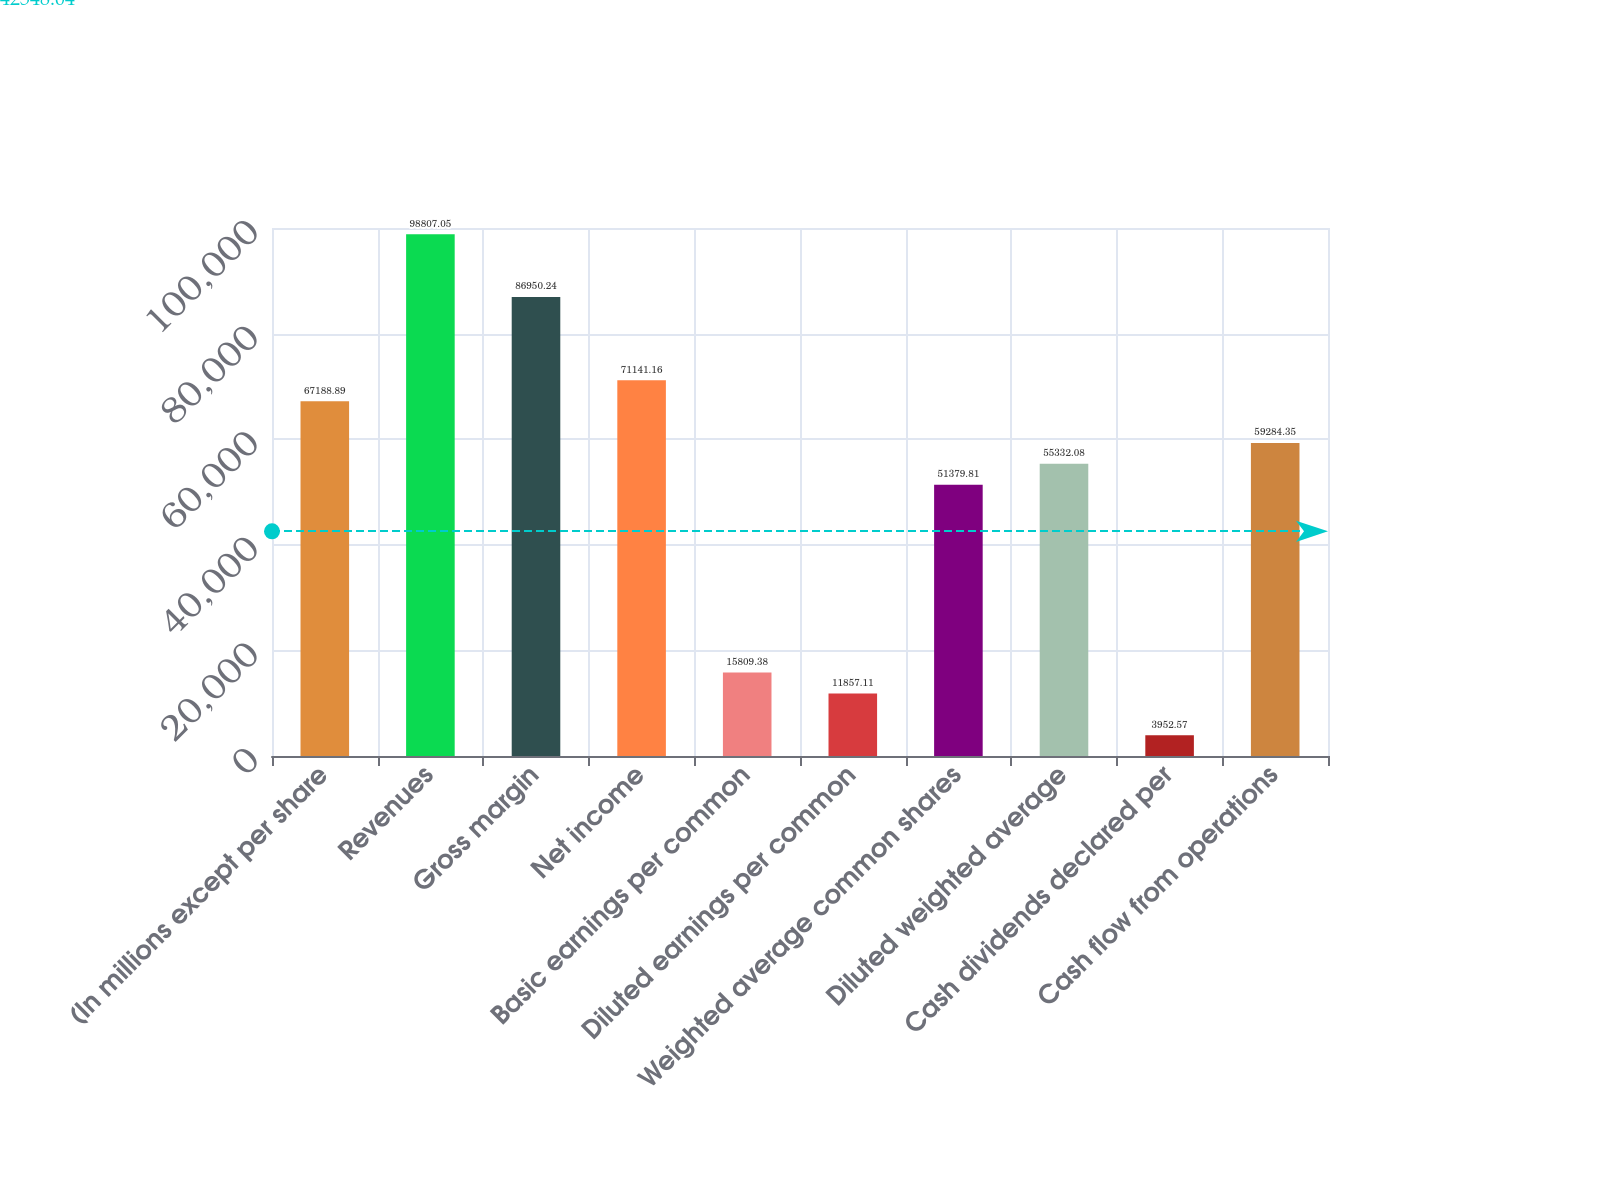Convert chart to OTSL. <chart><loc_0><loc_0><loc_500><loc_500><bar_chart><fcel>(In millions except per share<fcel>Revenues<fcel>Gross margin<fcel>Net income<fcel>Basic earnings per common<fcel>Diluted earnings per common<fcel>Weighted average common shares<fcel>Diluted weighted average<fcel>Cash dividends declared per<fcel>Cash flow from operations<nl><fcel>67188.9<fcel>98807.1<fcel>86950.2<fcel>71141.2<fcel>15809.4<fcel>11857.1<fcel>51379.8<fcel>55332.1<fcel>3952.57<fcel>59284.3<nl></chart> 